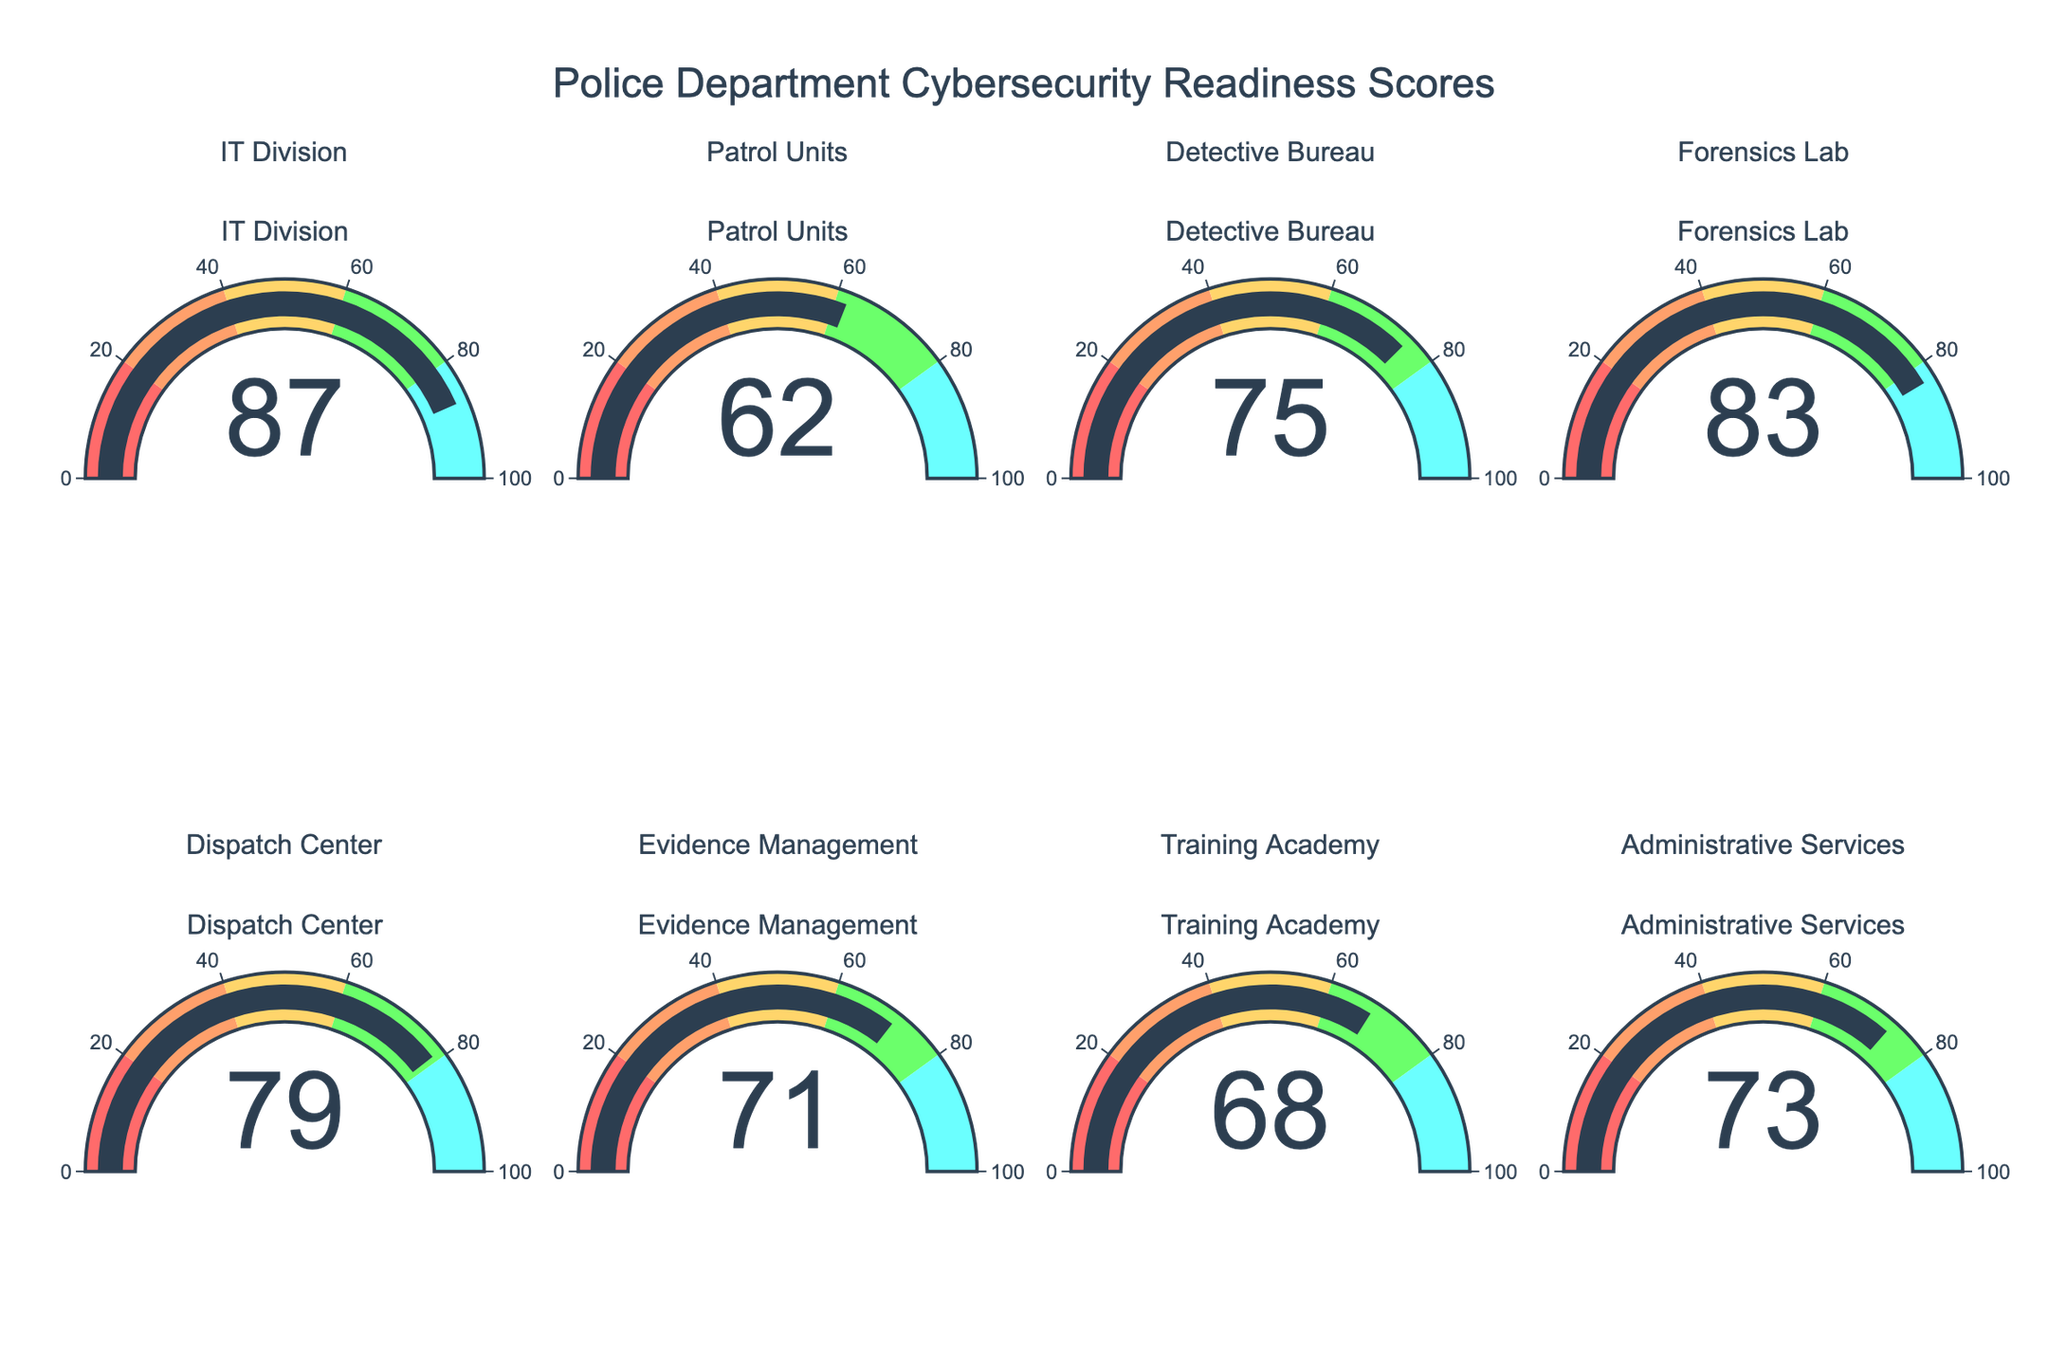What's the highest cybersecurity readiness score among the departments? The highest score can be found by examining the highest value displayed on the gauge charts. By looking at each gauge, the highest score is 87 from the IT Division.
Answer: 87 Which department has the lowest cybersecurity readiness score? The lowest score can be determined by identifying the smallest value displayed on the gauge charts. The Patrol Units have the lowest score with a value of 62.
Answer: 62 What is the average cybersecurity readiness score across all departments? To find the average, add together all the scores and divide by the number of departments. The scores are 87, 62, 75, 83, 79, 71, 68, 73. Summing them gives 598, and dividing by 8 gives 74.75.
Answer: 74.75 How many departments have a score above 70? Count the number of gauges with values greater than 70. The departments with scores above 70 are IT Division (87), Detective Bureau (75), Forensics Lab (83), Dispatch Center (79), Evidence Management (71), and Administrative Services (73). There are 6 such departments.
Answer: 6 Which department has a cybersecurity readiness score closest to the median score? First, order the scores from lowest to highest: 62, 68, 71, 73, 75, 79, 83, 87. The median value for an even number of entries is the average of the 4th and 5th values: (73 + 75)/2 = 74. There are two departments that are 1 unit away from this median: Detective Bureau (75) and Administrative Services (73).
Answer: Detective Bureau and Administrative Services Which department's readiness score is in the 60-80 range and closest to the middle of that range? First, identify all departments with scores within the 60-80 range: Patrol Units (62), Detective Bureau (75), Evidence Management (71), Training Academy (68), Administrative Services (73), Dispatch Center (79). The middle of the 60-80 range is 70. The department closest to this value is Evidence Management (71).
Answer: Evidence Management What is the difference in cybersecurity readiness scores between the IT Division and the Patrol Units? Subtract the score of the Patrol Units from the score of the IT Division: 87 - 62 = 25.
Answer: 25 Is the Forensics Lab's cybersecurity readiness score higher than the average score? The Forensics Lab's score is 83. As calculated previously, the average score is 74.75. Since 83 > 74.75, the Forensics Lab's score is higher than the average.
Answer: Yes 